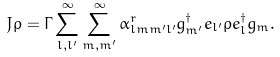<formula> <loc_0><loc_0><loc_500><loc_500>J \rho = \Gamma \sum _ { l , l ^ { \prime } } ^ { \infty } \sum _ { m , m ^ { \prime } } ^ { \infty } \alpha _ { l m m ^ { \prime } l ^ { \prime } } ^ { r } g ^ { \dagger } _ { m ^ { \prime } } e _ { l ^ { \prime } } \rho e ^ { \dagger } _ { l } g _ { m } .</formula> 